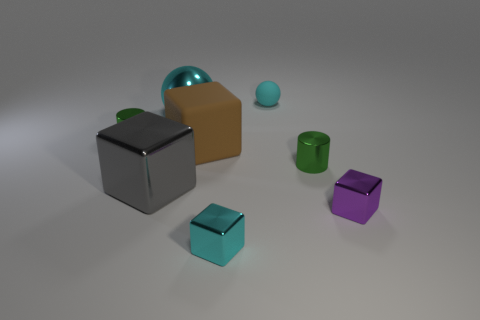There is a tiny cylinder in front of the tiny green cylinder behind the green metal cylinder that is right of the rubber sphere; what is its material? metal 